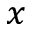Convert formula to latex. <formula><loc_0><loc_0><loc_500><loc_500>x</formula> 